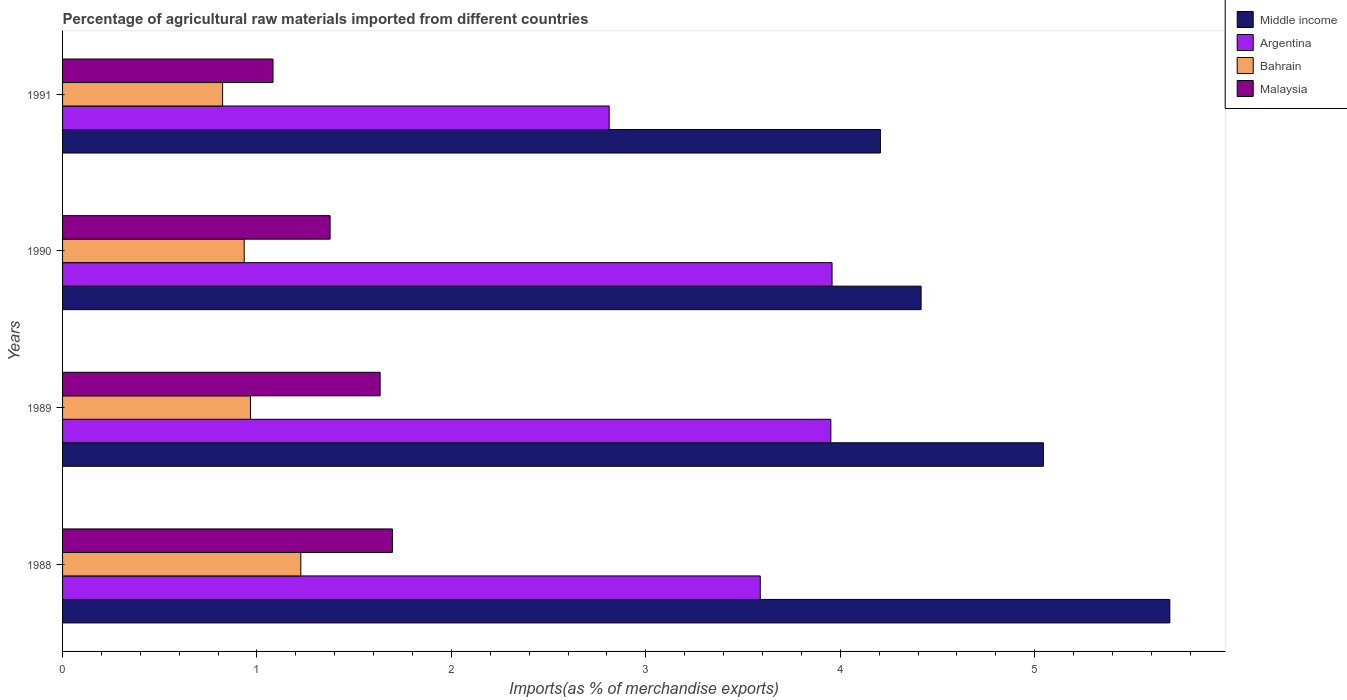How many bars are there on the 3rd tick from the top?
Your response must be concise. 4. How many bars are there on the 3rd tick from the bottom?
Provide a succinct answer. 4. What is the percentage of imports to different countries in Malaysia in 1990?
Your answer should be very brief. 1.38. Across all years, what is the maximum percentage of imports to different countries in Malaysia?
Provide a short and direct response. 1.7. Across all years, what is the minimum percentage of imports to different countries in Malaysia?
Offer a terse response. 1.08. In which year was the percentage of imports to different countries in Malaysia minimum?
Ensure brevity in your answer.  1991. What is the total percentage of imports to different countries in Bahrain in the graph?
Your answer should be compact. 3.95. What is the difference between the percentage of imports to different countries in Argentina in 1990 and that in 1991?
Offer a very short reply. 1.15. What is the difference between the percentage of imports to different countries in Bahrain in 1990 and the percentage of imports to different countries in Middle income in 1988?
Provide a succinct answer. -4.76. What is the average percentage of imports to different countries in Malaysia per year?
Offer a terse response. 1.45. In the year 1991, what is the difference between the percentage of imports to different countries in Middle income and percentage of imports to different countries in Malaysia?
Provide a short and direct response. 3.12. What is the ratio of the percentage of imports to different countries in Bahrain in 1989 to that in 1990?
Your answer should be very brief. 1.03. Is the percentage of imports to different countries in Middle income in 1989 less than that in 1990?
Your answer should be very brief. No. What is the difference between the highest and the second highest percentage of imports to different countries in Bahrain?
Make the answer very short. 0.26. What is the difference between the highest and the lowest percentage of imports to different countries in Middle income?
Your answer should be compact. 1.49. Is the sum of the percentage of imports to different countries in Malaysia in 1988 and 1989 greater than the maximum percentage of imports to different countries in Bahrain across all years?
Make the answer very short. Yes. Is it the case that in every year, the sum of the percentage of imports to different countries in Malaysia and percentage of imports to different countries in Bahrain is greater than the sum of percentage of imports to different countries in Argentina and percentage of imports to different countries in Middle income?
Provide a short and direct response. No. What does the 1st bar from the top in 1989 represents?
Offer a terse response. Malaysia. What does the 3rd bar from the bottom in 1988 represents?
Your answer should be compact. Bahrain. Are all the bars in the graph horizontal?
Your answer should be very brief. Yes. What is the difference between two consecutive major ticks on the X-axis?
Your response must be concise. 1. Are the values on the major ticks of X-axis written in scientific E-notation?
Your answer should be very brief. No. How are the legend labels stacked?
Your response must be concise. Vertical. What is the title of the graph?
Provide a succinct answer. Percentage of agricultural raw materials imported from different countries. Does "Ghana" appear as one of the legend labels in the graph?
Your answer should be compact. No. What is the label or title of the X-axis?
Your response must be concise. Imports(as % of merchandise exports). What is the label or title of the Y-axis?
Your answer should be compact. Years. What is the Imports(as % of merchandise exports) of Middle income in 1988?
Your answer should be compact. 5.7. What is the Imports(as % of merchandise exports) in Argentina in 1988?
Keep it short and to the point. 3.59. What is the Imports(as % of merchandise exports) in Bahrain in 1988?
Your answer should be very brief. 1.23. What is the Imports(as % of merchandise exports) in Malaysia in 1988?
Offer a very short reply. 1.7. What is the Imports(as % of merchandise exports) of Middle income in 1989?
Offer a very short reply. 5.04. What is the Imports(as % of merchandise exports) in Argentina in 1989?
Provide a succinct answer. 3.95. What is the Imports(as % of merchandise exports) of Bahrain in 1989?
Offer a very short reply. 0.97. What is the Imports(as % of merchandise exports) in Malaysia in 1989?
Provide a succinct answer. 1.63. What is the Imports(as % of merchandise exports) of Middle income in 1990?
Ensure brevity in your answer.  4.42. What is the Imports(as % of merchandise exports) in Argentina in 1990?
Keep it short and to the point. 3.96. What is the Imports(as % of merchandise exports) of Bahrain in 1990?
Make the answer very short. 0.93. What is the Imports(as % of merchandise exports) of Malaysia in 1990?
Your answer should be compact. 1.38. What is the Imports(as % of merchandise exports) in Middle income in 1991?
Keep it short and to the point. 4.21. What is the Imports(as % of merchandise exports) in Argentina in 1991?
Keep it short and to the point. 2.81. What is the Imports(as % of merchandise exports) in Bahrain in 1991?
Provide a short and direct response. 0.82. What is the Imports(as % of merchandise exports) of Malaysia in 1991?
Provide a short and direct response. 1.08. Across all years, what is the maximum Imports(as % of merchandise exports) of Middle income?
Provide a succinct answer. 5.7. Across all years, what is the maximum Imports(as % of merchandise exports) in Argentina?
Keep it short and to the point. 3.96. Across all years, what is the maximum Imports(as % of merchandise exports) in Bahrain?
Provide a short and direct response. 1.23. Across all years, what is the maximum Imports(as % of merchandise exports) of Malaysia?
Make the answer very short. 1.7. Across all years, what is the minimum Imports(as % of merchandise exports) of Middle income?
Offer a terse response. 4.21. Across all years, what is the minimum Imports(as % of merchandise exports) of Argentina?
Your answer should be compact. 2.81. Across all years, what is the minimum Imports(as % of merchandise exports) in Bahrain?
Keep it short and to the point. 0.82. Across all years, what is the minimum Imports(as % of merchandise exports) of Malaysia?
Your answer should be compact. 1.08. What is the total Imports(as % of merchandise exports) of Middle income in the graph?
Offer a terse response. 19.36. What is the total Imports(as % of merchandise exports) of Argentina in the graph?
Provide a short and direct response. 14.31. What is the total Imports(as % of merchandise exports) of Bahrain in the graph?
Provide a succinct answer. 3.95. What is the total Imports(as % of merchandise exports) of Malaysia in the graph?
Provide a succinct answer. 5.79. What is the difference between the Imports(as % of merchandise exports) in Middle income in 1988 and that in 1989?
Ensure brevity in your answer.  0.65. What is the difference between the Imports(as % of merchandise exports) of Argentina in 1988 and that in 1989?
Give a very brief answer. -0.36. What is the difference between the Imports(as % of merchandise exports) of Bahrain in 1988 and that in 1989?
Provide a short and direct response. 0.26. What is the difference between the Imports(as % of merchandise exports) of Malaysia in 1988 and that in 1989?
Provide a succinct answer. 0.06. What is the difference between the Imports(as % of merchandise exports) of Middle income in 1988 and that in 1990?
Your answer should be very brief. 1.28. What is the difference between the Imports(as % of merchandise exports) in Argentina in 1988 and that in 1990?
Your answer should be very brief. -0.37. What is the difference between the Imports(as % of merchandise exports) in Bahrain in 1988 and that in 1990?
Offer a terse response. 0.29. What is the difference between the Imports(as % of merchandise exports) of Malaysia in 1988 and that in 1990?
Give a very brief answer. 0.32. What is the difference between the Imports(as % of merchandise exports) of Middle income in 1988 and that in 1991?
Offer a very short reply. 1.49. What is the difference between the Imports(as % of merchandise exports) of Argentina in 1988 and that in 1991?
Ensure brevity in your answer.  0.78. What is the difference between the Imports(as % of merchandise exports) in Bahrain in 1988 and that in 1991?
Your response must be concise. 0.4. What is the difference between the Imports(as % of merchandise exports) in Malaysia in 1988 and that in 1991?
Provide a short and direct response. 0.61. What is the difference between the Imports(as % of merchandise exports) in Middle income in 1989 and that in 1990?
Keep it short and to the point. 0.63. What is the difference between the Imports(as % of merchandise exports) of Argentina in 1989 and that in 1990?
Provide a succinct answer. -0.01. What is the difference between the Imports(as % of merchandise exports) of Bahrain in 1989 and that in 1990?
Your answer should be compact. 0.03. What is the difference between the Imports(as % of merchandise exports) of Malaysia in 1989 and that in 1990?
Make the answer very short. 0.26. What is the difference between the Imports(as % of merchandise exports) of Middle income in 1989 and that in 1991?
Make the answer very short. 0.84. What is the difference between the Imports(as % of merchandise exports) of Argentina in 1989 and that in 1991?
Offer a terse response. 1.14. What is the difference between the Imports(as % of merchandise exports) in Bahrain in 1989 and that in 1991?
Offer a very short reply. 0.14. What is the difference between the Imports(as % of merchandise exports) in Malaysia in 1989 and that in 1991?
Your answer should be compact. 0.55. What is the difference between the Imports(as % of merchandise exports) of Middle income in 1990 and that in 1991?
Your answer should be very brief. 0.21. What is the difference between the Imports(as % of merchandise exports) in Argentina in 1990 and that in 1991?
Ensure brevity in your answer.  1.15. What is the difference between the Imports(as % of merchandise exports) in Bahrain in 1990 and that in 1991?
Offer a very short reply. 0.11. What is the difference between the Imports(as % of merchandise exports) of Malaysia in 1990 and that in 1991?
Ensure brevity in your answer.  0.29. What is the difference between the Imports(as % of merchandise exports) of Middle income in 1988 and the Imports(as % of merchandise exports) of Argentina in 1989?
Keep it short and to the point. 1.74. What is the difference between the Imports(as % of merchandise exports) in Middle income in 1988 and the Imports(as % of merchandise exports) in Bahrain in 1989?
Offer a very short reply. 4.73. What is the difference between the Imports(as % of merchandise exports) in Middle income in 1988 and the Imports(as % of merchandise exports) in Malaysia in 1989?
Provide a short and direct response. 4.06. What is the difference between the Imports(as % of merchandise exports) of Argentina in 1988 and the Imports(as % of merchandise exports) of Bahrain in 1989?
Provide a succinct answer. 2.62. What is the difference between the Imports(as % of merchandise exports) in Argentina in 1988 and the Imports(as % of merchandise exports) in Malaysia in 1989?
Your answer should be very brief. 1.96. What is the difference between the Imports(as % of merchandise exports) of Bahrain in 1988 and the Imports(as % of merchandise exports) of Malaysia in 1989?
Provide a short and direct response. -0.41. What is the difference between the Imports(as % of merchandise exports) of Middle income in 1988 and the Imports(as % of merchandise exports) of Argentina in 1990?
Give a very brief answer. 1.74. What is the difference between the Imports(as % of merchandise exports) in Middle income in 1988 and the Imports(as % of merchandise exports) in Bahrain in 1990?
Offer a terse response. 4.76. What is the difference between the Imports(as % of merchandise exports) of Middle income in 1988 and the Imports(as % of merchandise exports) of Malaysia in 1990?
Offer a terse response. 4.32. What is the difference between the Imports(as % of merchandise exports) in Argentina in 1988 and the Imports(as % of merchandise exports) in Bahrain in 1990?
Provide a short and direct response. 2.65. What is the difference between the Imports(as % of merchandise exports) of Argentina in 1988 and the Imports(as % of merchandise exports) of Malaysia in 1990?
Keep it short and to the point. 2.21. What is the difference between the Imports(as % of merchandise exports) of Bahrain in 1988 and the Imports(as % of merchandise exports) of Malaysia in 1990?
Your response must be concise. -0.15. What is the difference between the Imports(as % of merchandise exports) of Middle income in 1988 and the Imports(as % of merchandise exports) of Argentina in 1991?
Provide a short and direct response. 2.88. What is the difference between the Imports(as % of merchandise exports) of Middle income in 1988 and the Imports(as % of merchandise exports) of Bahrain in 1991?
Your response must be concise. 4.87. What is the difference between the Imports(as % of merchandise exports) in Middle income in 1988 and the Imports(as % of merchandise exports) in Malaysia in 1991?
Offer a very short reply. 4.61. What is the difference between the Imports(as % of merchandise exports) of Argentina in 1988 and the Imports(as % of merchandise exports) of Bahrain in 1991?
Your response must be concise. 2.77. What is the difference between the Imports(as % of merchandise exports) in Argentina in 1988 and the Imports(as % of merchandise exports) in Malaysia in 1991?
Give a very brief answer. 2.51. What is the difference between the Imports(as % of merchandise exports) in Bahrain in 1988 and the Imports(as % of merchandise exports) in Malaysia in 1991?
Provide a short and direct response. 0.14. What is the difference between the Imports(as % of merchandise exports) of Middle income in 1989 and the Imports(as % of merchandise exports) of Argentina in 1990?
Offer a very short reply. 1.09. What is the difference between the Imports(as % of merchandise exports) of Middle income in 1989 and the Imports(as % of merchandise exports) of Bahrain in 1990?
Offer a very short reply. 4.11. What is the difference between the Imports(as % of merchandise exports) in Middle income in 1989 and the Imports(as % of merchandise exports) in Malaysia in 1990?
Make the answer very short. 3.67. What is the difference between the Imports(as % of merchandise exports) in Argentina in 1989 and the Imports(as % of merchandise exports) in Bahrain in 1990?
Keep it short and to the point. 3.02. What is the difference between the Imports(as % of merchandise exports) of Argentina in 1989 and the Imports(as % of merchandise exports) of Malaysia in 1990?
Your response must be concise. 2.58. What is the difference between the Imports(as % of merchandise exports) of Bahrain in 1989 and the Imports(as % of merchandise exports) of Malaysia in 1990?
Provide a short and direct response. -0.41. What is the difference between the Imports(as % of merchandise exports) of Middle income in 1989 and the Imports(as % of merchandise exports) of Argentina in 1991?
Your answer should be very brief. 2.23. What is the difference between the Imports(as % of merchandise exports) of Middle income in 1989 and the Imports(as % of merchandise exports) of Bahrain in 1991?
Give a very brief answer. 4.22. What is the difference between the Imports(as % of merchandise exports) in Middle income in 1989 and the Imports(as % of merchandise exports) in Malaysia in 1991?
Give a very brief answer. 3.96. What is the difference between the Imports(as % of merchandise exports) of Argentina in 1989 and the Imports(as % of merchandise exports) of Bahrain in 1991?
Your answer should be very brief. 3.13. What is the difference between the Imports(as % of merchandise exports) of Argentina in 1989 and the Imports(as % of merchandise exports) of Malaysia in 1991?
Keep it short and to the point. 2.87. What is the difference between the Imports(as % of merchandise exports) of Bahrain in 1989 and the Imports(as % of merchandise exports) of Malaysia in 1991?
Keep it short and to the point. -0.12. What is the difference between the Imports(as % of merchandise exports) in Middle income in 1990 and the Imports(as % of merchandise exports) in Argentina in 1991?
Your response must be concise. 1.6. What is the difference between the Imports(as % of merchandise exports) of Middle income in 1990 and the Imports(as % of merchandise exports) of Bahrain in 1991?
Provide a succinct answer. 3.59. What is the difference between the Imports(as % of merchandise exports) of Middle income in 1990 and the Imports(as % of merchandise exports) of Malaysia in 1991?
Make the answer very short. 3.33. What is the difference between the Imports(as % of merchandise exports) of Argentina in 1990 and the Imports(as % of merchandise exports) of Bahrain in 1991?
Provide a succinct answer. 3.13. What is the difference between the Imports(as % of merchandise exports) in Argentina in 1990 and the Imports(as % of merchandise exports) in Malaysia in 1991?
Your answer should be compact. 2.88. What is the difference between the Imports(as % of merchandise exports) in Bahrain in 1990 and the Imports(as % of merchandise exports) in Malaysia in 1991?
Give a very brief answer. -0.15. What is the average Imports(as % of merchandise exports) in Middle income per year?
Offer a very short reply. 4.84. What is the average Imports(as % of merchandise exports) of Argentina per year?
Give a very brief answer. 3.58. What is the average Imports(as % of merchandise exports) of Bahrain per year?
Your answer should be compact. 0.99. What is the average Imports(as % of merchandise exports) of Malaysia per year?
Make the answer very short. 1.45. In the year 1988, what is the difference between the Imports(as % of merchandise exports) of Middle income and Imports(as % of merchandise exports) of Argentina?
Provide a succinct answer. 2.11. In the year 1988, what is the difference between the Imports(as % of merchandise exports) of Middle income and Imports(as % of merchandise exports) of Bahrain?
Your response must be concise. 4.47. In the year 1988, what is the difference between the Imports(as % of merchandise exports) of Middle income and Imports(as % of merchandise exports) of Malaysia?
Keep it short and to the point. 4. In the year 1988, what is the difference between the Imports(as % of merchandise exports) of Argentina and Imports(as % of merchandise exports) of Bahrain?
Your answer should be compact. 2.36. In the year 1988, what is the difference between the Imports(as % of merchandise exports) in Argentina and Imports(as % of merchandise exports) in Malaysia?
Offer a terse response. 1.89. In the year 1988, what is the difference between the Imports(as % of merchandise exports) in Bahrain and Imports(as % of merchandise exports) in Malaysia?
Provide a succinct answer. -0.47. In the year 1989, what is the difference between the Imports(as % of merchandise exports) in Middle income and Imports(as % of merchandise exports) in Argentina?
Offer a very short reply. 1.09. In the year 1989, what is the difference between the Imports(as % of merchandise exports) of Middle income and Imports(as % of merchandise exports) of Bahrain?
Ensure brevity in your answer.  4.08. In the year 1989, what is the difference between the Imports(as % of merchandise exports) of Middle income and Imports(as % of merchandise exports) of Malaysia?
Make the answer very short. 3.41. In the year 1989, what is the difference between the Imports(as % of merchandise exports) of Argentina and Imports(as % of merchandise exports) of Bahrain?
Offer a terse response. 2.99. In the year 1989, what is the difference between the Imports(as % of merchandise exports) in Argentina and Imports(as % of merchandise exports) in Malaysia?
Make the answer very short. 2.32. In the year 1989, what is the difference between the Imports(as % of merchandise exports) in Bahrain and Imports(as % of merchandise exports) in Malaysia?
Give a very brief answer. -0.67. In the year 1990, what is the difference between the Imports(as % of merchandise exports) in Middle income and Imports(as % of merchandise exports) in Argentina?
Provide a succinct answer. 0.46. In the year 1990, what is the difference between the Imports(as % of merchandise exports) of Middle income and Imports(as % of merchandise exports) of Bahrain?
Give a very brief answer. 3.48. In the year 1990, what is the difference between the Imports(as % of merchandise exports) of Middle income and Imports(as % of merchandise exports) of Malaysia?
Make the answer very short. 3.04. In the year 1990, what is the difference between the Imports(as % of merchandise exports) in Argentina and Imports(as % of merchandise exports) in Bahrain?
Your answer should be very brief. 3.02. In the year 1990, what is the difference between the Imports(as % of merchandise exports) of Argentina and Imports(as % of merchandise exports) of Malaysia?
Make the answer very short. 2.58. In the year 1990, what is the difference between the Imports(as % of merchandise exports) in Bahrain and Imports(as % of merchandise exports) in Malaysia?
Provide a succinct answer. -0.44. In the year 1991, what is the difference between the Imports(as % of merchandise exports) of Middle income and Imports(as % of merchandise exports) of Argentina?
Your answer should be very brief. 1.4. In the year 1991, what is the difference between the Imports(as % of merchandise exports) in Middle income and Imports(as % of merchandise exports) in Bahrain?
Make the answer very short. 3.38. In the year 1991, what is the difference between the Imports(as % of merchandise exports) in Middle income and Imports(as % of merchandise exports) in Malaysia?
Offer a very short reply. 3.12. In the year 1991, what is the difference between the Imports(as % of merchandise exports) of Argentina and Imports(as % of merchandise exports) of Bahrain?
Your response must be concise. 1.99. In the year 1991, what is the difference between the Imports(as % of merchandise exports) of Argentina and Imports(as % of merchandise exports) of Malaysia?
Offer a terse response. 1.73. In the year 1991, what is the difference between the Imports(as % of merchandise exports) in Bahrain and Imports(as % of merchandise exports) in Malaysia?
Ensure brevity in your answer.  -0.26. What is the ratio of the Imports(as % of merchandise exports) in Middle income in 1988 to that in 1989?
Provide a short and direct response. 1.13. What is the ratio of the Imports(as % of merchandise exports) of Argentina in 1988 to that in 1989?
Give a very brief answer. 0.91. What is the ratio of the Imports(as % of merchandise exports) in Bahrain in 1988 to that in 1989?
Provide a succinct answer. 1.27. What is the ratio of the Imports(as % of merchandise exports) of Malaysia in 1988 to that in 1989?
Give a very brief answer. 1.04. What is the ratio of the Imports(as % of merchandise exports) of Middle income in 1988 to that in 1990?
Your answer should be very brief. 1.29. What is the ratio of the Imports(as % of merchandise exports) of Argentina in 1988 to that in 1990?
Your answer should be very brief. 0.91. What is the ratio of the Imports(as % of merchandise exports) of Bahrain in 1988 to that in 1990?
Provide a short and direct response. 1.31. What is the ratio of the Imports(as % of merchandise exports) of Malaysia in 1988 to that in 1990?
Your answer should be compact. 1.23. What is the ratio of the Imports(as % of merchandise exports) in Middle income in 1988 to that in 1991?
Provide a short and direct response. 1.35. What is the ratio of the Imports(as % of merchandise exports) in Argentina in 1988 to that in 1991?
Ensure brevity in your answer.  1.28. What is the ratio of the Imports(as % of merchandise exports) of Bahrain in 1988 to that in 1991?
Offer a very short reply. 1.49. What is the ratio of the Imports(as % of merchandise exports) of Malaysia in 1988 to that in 1991?
Your response must be concise. 1.57. What is the ratio of the Imports(as % of merchandise exports) of Middle income in 1989 to that in 1990?
Your answer should be very brief. 1.14. What is the ratio of the Imports(as % of merchandise exports) in Bahrain in 1989 to that in 1990?
Your response must be concise. 1.03. What is the ratio of the Imports(as % of merchandise exports) of Malaysia in 1989 to that in 1990?
Make the answer very short. 1.19. What is the ratio of the Imports(as % of merchandise exports) of Middle income in 1989 to that in 1991?
Make the answer very short. 1.2. What is the ratio of the Imports(as % of merchandise exports) in Argentina in 1989 to that in 1991?
Your response must be concise. 1.41. What is the ratio of the Imports(as % of merchandise exports) in Bahrain in 1989 to that in 1991?
Your answer should be very brief. 1.17. What is the ratio of the Imports(as % of merchandise exports) of Malaysia in 1989 to that in 1991?
Your response must be concise. 1.51. What is the ratio of the Imports(as % of merchandise exports) of Middle income in 1990 to that in 1991?
Provide a succinct answer. 1.05. What is the ratio of the Imports(as % of merchandise exports) of Argentina in 1990 to that in 1991?
Give a very brief answer. 1.41. What is the ratio of the Imports(as % of merchandise exports) of Bahrain in 1990 to that in 1991?
Provide a succinct answer. 1.13. What is the ratio of the Imports(as % of merchandise exports) in Malaysia in 1990 to that in 1991?
Offer a very short reply. 1.27. What is the difference between the highest and the second highest Imports(as % of merchandise exports) in Middle income?
Give a very brief answer. 0.65. What is the difference between the highest and the second highest Imports(as % of merchandise exports) in Argentina?
Your answer should be very brief. 0.01. What is the difference between the highest and the second highest Imports(as % of merchandise exports) in Bahrain?
Your answer should be compact. 0.26. What is the difference between the highest and the second highest Imports(as % of merchandise exports) of Malaysia?
Ensure brevity in your answer.  0.06. What is the difference between the highest and the lowest Imports(as % of merchandise exports) in Middle income?
Make the answer very short. 1.49. What is the difference between the highest and the lowest Imports(as % of merchandise exports) of Argentina?
Provide a succinct answer. 1.15. What is the difference between the highest and the lowest Imports(as % of merchandise exports) of Bahrain?
Give a very brief answer. 0.4. What is the difference between the highest and the lowest Imports(as % of merchandise exports) in Malaysia?
Provide a succinct answer. 0.61. 